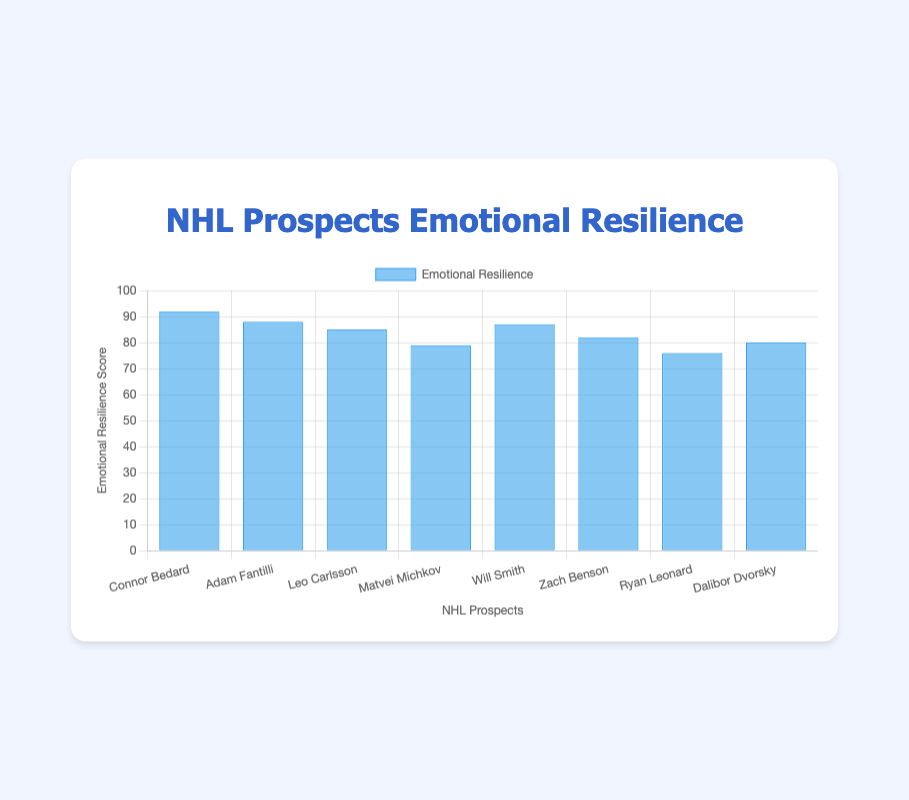What is the title of the chart? The title of the chart is located at the top and it reads "NHL Prospects Emotional Resilience".
Answer: NHL Prospects Emotional Resilience What are the labels on the x-axis? The x-axis represents the NHL prospects' names and is labeled with their names: Connor Bedard, Adam Fantilli, Leo Carlsson, Matvei Michkov, Will Smith, Zach Benson, Ryan Leonard, and Dalibor Dvorsky.
Answer: NHL prospects' names Which prospect has the highest emotional resilience score and what is it? By looking at the bar heights, Connor Bedard has the highest emotional resilience score of 92.
Answer: Connor Bedard, 92 How many prospects have an emotional resilience score above 85? From the chart, we can see that Connor Bedard (92), Adam Fantilli (88), Leo Carlsson (85), and Will Smith (87) have scores above 85.
Answer: 4 prospects What is the average emotional resilience score of the prospects? Add all the scores (92 + 88 + 85 + 79 + 87 + 82 + 76 + 80) to get 669, then divide by the number of prospects (8) to find the average: 669/8 = 83.625
Answer: 83.625 Which prospect has the lowest emotional resilience score and what is it? By examining the shortest bar, Ryan Leonard has the lowest emotional resilience score of 76.
Answer: Ryan Leonard, 76 Compare the stress levels between Matvei Michkov and Dalibor Dvorsky. Which one shows higher stress? Matvei Michkov has a "😐" stress level, while Dalibor Dvorsky also has a "😐". Both prospects have the same stress level, which is neutral.
Answer: They are the same (😐) What is the combined emotional resilience score of Adam Fantilli and Will Smith? Adam Fantilli has a score of 88, and Will Smith has a score of 87. The combined score is 88 + 87 = 175.
Answer: 175 Which prospect has a better emotional resilience score, Leo Carlsson or Zach Benson? Leo Carlsson's score is 85, and Zach Benson's score is 82. Leo Carlsson has a higher score.
Answer: Leo Carlsson What is the difference in emotional resilience scores between the prospect with the highest and the lowest scores? The highest score is 92 (Connor Bedard) and the lowest is 76 (Ryan Leonard). The difference is 92 - 76 = 16.
Answer: 16 